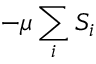Convert formula to latex. <formula><loc_0><loc_0><loc_500><loc_500>- \mu \sum _ { i } S _ { i }</formula> 